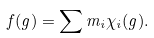<formula> <loc_0><loc_0><loc_500><loc_500>f ( g ) = \sum m _ { i } \chi _ { i } ( g ) .</formula> 